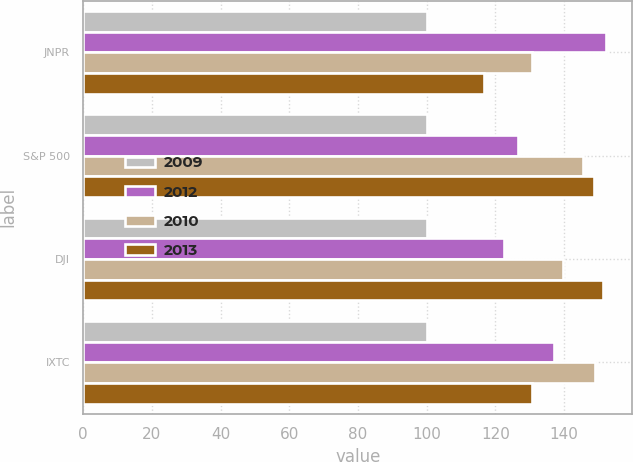<chart> <loc_0><loc_0><loc_500><loc_500><stacked_bar_chart><ecel><fcel>JNPR<fcel>S&P 500<fcel>DJI<fcel>IXTC<nl><fcel>2009<fcel>100<fcel>100<fcel>100<fcel>100<nl><fcel>2012<fcel>152.31<fcel>126.46<fcel>122.6<fcel>137.19<nl><fcel>2010<fcel>130.81<fcel>145.51<fcel>139.81<fcel>148.93<nl><fcel>2013<fcel>116.56<fcel>148.59<fcel>151.47<fcel>130.81<nl></chart> 